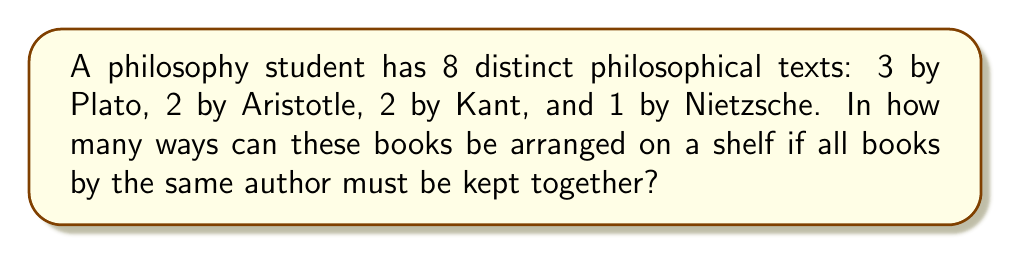Teach me how to tackle this problem. Let's approach this step-by-step:

1) First, consider the groups of books as units:
   - Plato's books (3) as one unit
   - Aristotle's books (2) as one unit
   - Kant's books (2) as one unit
   - Nietzsche's book (1) as one unit

2) We need to arrange these 4 units. This can be done in $4!$ ways.

3) Now, within each group, we need to consider the arrangements:
   - Plato's 3 books can be arranged in $3!$ ways
   - Aristotle's 2 books can be arranged in $2!$ ways
   - Kant's 2 books can be arranged in $2!$ ways
   - Nietzsche's single book has only 1 way to be arranged

4) By the multiplication principle, the total number of arrangements is:

   $$ 4! \times 3! \times 2! \times 2! \times 1! $$

5) Let's calculate:
   $$ 24 \times 6 \times 2 \times 2 \times 1 = 576 $$

This problem demonstrates the application of the multiplication principle in permutations, a key concept in logical thinking and problem-solving.
Answer: 576 